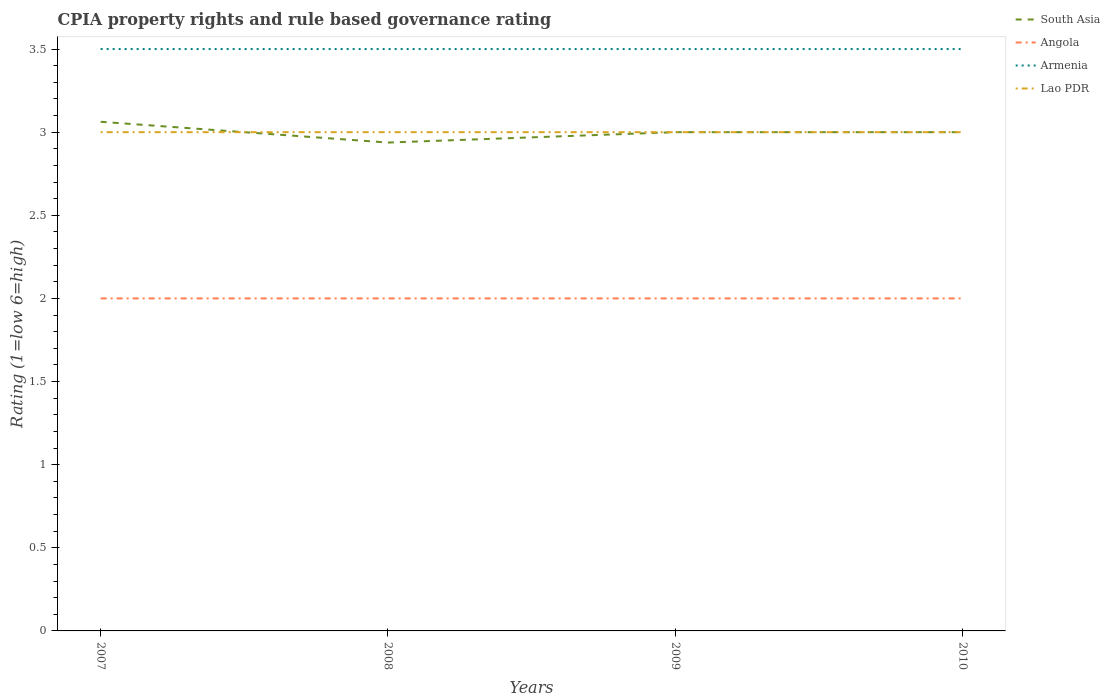How many different coloured lines are there?
Provide a short and direct response. 4. Does the line corresponding to Lao PDR intersect with the line corresponding to Angola?
Offer a very short reply. No. Is the number of lines equal to the number of legend labels?
Give a very brief answer. Yes. Across all years, what is the maximum CPIA rating in South Asia?
Keep it short and to the point. 2.94. In which year was the CPIA rating in Armenia maximum?
Give a very brief answer. 2007. What is the total CPIA rating in South Asia in the graph?
Keep it short and to the point. 0. What is the difference between the highest and the second highest CPIA rating in Lao PDR?
Make the answer very short. 0. What is the difference between the highest and the lowest CPIA rating in Angola?
Provide a succinct answer. 0. What is the difference between two consecutive major ticks on the Y-axis?
Offer a terse response. 0.5. Does the graph contain grids?
Your answer should be very brief. No. How many legend labels are there?
Make the answer very short. 4. How are the legend labels stacked?
Your answer should be very brief. Vertical. What is the title of the graph?
Your response must be concise. CPIA property rights and rule based governance rating. Does "United Kingdom" appear as one of the legend labels in the graph?
Give a very brief answer. No. What is the Rating (1=low 6=high) in South Asia in 2007?
Your response must be concise. 3.06. What is the Rating (1=low 6=high) in Angola in 2007?
Ensure brevity in your answer.  2. What is the Rating (1=low 6=high) in Lao PDR in 2007?
Your response must be concise. 3. What is the Rating (1=low 6=high) of South Asia in 2008?
Make the answer very short. 2.94. What is the Rating (1=low 6=high) of Angola in 2008?
Provide a short and direct response. 2. What is the Rating (1=low 6=high) in Armenia in 2008?
Your answer should be very brief. 3.5. What is the Rating (1=low 6=high) in South Asia in 2009?
Make the answer very short. 3. What is the Rating (1=low 6=high) in Angola in 2009?
Ensure brevity in your answer.  2. What is the Rating (1=low 6=high) in Armenia in 2009?
Your answer should be compact. 3.5. What is the Rating (1=low 6=high) in Armenia in 2010?
Keep it short and to the point. 3.5. What is the Rating (1=low 6=high) in Lao PDR in 2010?
Your answer should be compact. 3. Across all years, what is the maximum Rating (1=low 6=high) in South Asia?
Your answer should be very brief. 3.06. Across all years, what is the maximum Rating (1=low 6=high) in Angola?
Make the answer very short. 2. Across all years, what is the maximum Rating (1=low 6=high) of Armenia?
Give a very brief answer. 3.5. Across all years, what is the maximum Rating (1=low 6=high) in Lao PDR?
Your answer should be very brief. 3. Across all years, what is the minimum Rating (1=low 6=high) in South Asia?
Offer a terse response. 2.94. Across all years, what is the minimum Rating (1=low 6=high) in Angola?
Give a very brief answer. 2. Across all years, what is the minimum Rating (1=low 6=high) of Lao PDR?
Offer a terse response. 3. What is the total Rating (1=low 6=high) in Angola in the graph?
Your response must be concise. 8. What is the total Rating (1=low 6=high) of Lao PDR in the graph?
Provide a short and direct response. 12. What is the difference between the Rating (1=low 6=high) of Lao PDR in 2007 and that in 2008?
Offer a terse response. 0. What is the difference between the Rating (1=low 6=high) of South Asia in 2007 and that in 2009?
Your answer should be compact. 0.06. What is the difference between the Rating (1=low 6=high) of Armenia in 2007 and that in 2009?
Offer a terse response. 0. What is the difference between the Rating (1=low 6=high) of South Asia in 2007 and that in 2010?
Make the answer very short. 0.06. What is the difference between the Rating (1=low 6=high) of Angola in 2007 and that in 2010?
Keep it short and to the point. 0. What is the difference between the Rating (1=low 6=high) in South Asia in 2008 and that in 2009?
Provide a short and direct response. -0.06. What is the difference between the Rating (1=low 6=high) in South Asia in 2008 and that in 2010?
Provide a short and direct response. -0.06. What is the difference between the Rating (1=low 6=high) in Angola in 2008 and that in 2010?
Your answer should be compact. 0. What is the difference between the Rating (1=low 6=high) in Armenia in 2008 and that in 2010?
Ensure brevity in your answer.  0. What is the difference between the Rating (1=low 6=high) in Lao PDR in 2008 and that in 2010?
Offer a terse response. 0. What is the difference between the Rating (1=low 6=high) in South Asia in 2009 and that in 2010?
Your answer should be compact. 0. What is the difference between the Rating (1=low 6=high) in South Asia in 2007 and the Rating (1=low 6=high) in Armenia in 2008?
Offer a very short reply. -0.44. What is the difference between the Rating (1=low 6=high) of South Asia in 2007 and the Rating (1=low 6=high) of Lao PDR in 2008?
Your answer should be compact. 0.06. What is the difference between the Rating (1=low 6=high) of Angola in 2007 and the Rating (1=low 6=high) of Armenia in 2008?
Keep it short and to the point. -1.5. What is the difference between the Rating (1=low 6=high) in Armenia in 2007 and the Rating (1=low 6=high) in Lao PDR in 2008?
Offer a very short reply. 0.5. What is the difference between the Rating (1=low 6=high) in South Asia in 2007 and the Rating (1=low 6=high) in Angola in 2009?
Ensure brevity in your answer.  1.06. What is the difference between the Rating (1=low 6=high) of South Asia in 2007 and the Rating (1=low 6=high) of Armenia in 2009?
Ensure brevity in your answer.  -0.44. What is the difference between the Rating (1=low 6=high) in South Asia in 2007 and the Rating (1=low 6=high) in Lao PDR in 2009?
Your answer should be compact. 0.06. What is the difference between the Rating (1=low 6=high) in Angola in 2007 and the Rating (1=low 6=high) in Armenia in 2009?
Give a very brief answer. -1.5. What is the difference between the Rating (1=low 6=high) in Angola in 2007 and the Rating (1=low 6=high) in Lao PDR in 2009?
Your answer should be very brief. -1. What is the difference between the Rating (1=low 6=high) in South Asia in 2007 and the Rating (1=low 6=high) in Armenia in 2010?
Offer a very short reply. -0.44. What is the difference between the Rating (1=low 6=high) of South Asia in 2007 and the Rating (1=low 6=high) of Lao PDR in 2010?
Keep it short and to the point. 0.06. What is the difference between the Rating (1=low 6=high) in Armenia in 2007 and the Rating (1=low 6=high) in Lao PDR in 2010?
Offer a very short reply. 0.5. What is the difference between the Rating (1=low 6=high) in South Asia in 2008 and the Rating (1=low 6=high) in Armenia in 2009?
Keep it short and to the point. -0.56. What is the difference between the Rating (1=low 6=high) of South Asia in 2008 and the Rating (1=low 6=high) of Lao PDR in 2009?
Provide a short and direct response. -0.06. What is the difference between the Rating (1=low 6=high) of Angola in 2008 and the Rating (1=low 6=high) of Lao PDR in 2009?
Keep it short and to the point. -1. What is the difference between the Rating (1=low 6=high) of Armenia in 2008 and the Rating (1=low 6=high) of Lao PDR in 2009?
Your answer should be very brief. 0.5. What is the difference between the Rating (1=low 6=high) in South Asia in 2008 and the Rating (1=low 6=high) in Armenia in 2010?
Offer a very short reply. -0.56. What is the difference between the Rating (1=low 6=high) of South Asia in 2008 and the Rating (1=low 6=high) of Lao PDR in 2010?
Your response must be concise. -0.06. What is the difference between the Rating (1=low 6=high) of Angola in 2008 and the Rating (1=low 6=high) of Armenia in 2010?
Ensure brevity in your answer.  -1.5. What is the difference between the Rating (1=low 6=high) of Angola in 2008 and the Rating (1=low 6=high) of Lao PDR in 2010?
Your answer should be very brief. -1. What is the difference between the Rating (1=low 6=high) in Armenia in 2008 and the Rating (1=low 6=high) in Lao PDR in 2010?
Offer a very short reply. 0.5. What is the difference between the Rating (1=low 6=high) of South Asia in 2009 and the Rating (1=low 6=high) of Armenia in 2010?
Your response must be concise. -0.5. What is the difference between the Rating (1=low 6=high) in South Asia in 2009 and the Rating (1=low 6=high) in Lao PDR in 2010?
Offer a terse response. 0. What is the difference between the Rating (1=low 6=high) in Angola in 2009 and the Rating (1=low 6=high) in Lao PDR in 2010?
Offer a very short reply. -1. What is the difference between the Rating (1=low 6=high) of Armenia in 2009 and the Rating (1=low 6=high) of Lao PDR in 2010?
Offer a terse response. 0.5. What is the average Rating (1=low 6=high) in South Asia per year?
Keep it short and to the point. 3. In the year 2007, what is the difference between the Rating (1=low 6=high) of South Asia and Rating (1=low 6=high) of Armenia?
Make the answer very short. -0.44. In the year 2007, what is the difference between the Rating (1=low 6=high) of South Asia and Rating (1=low 6=high) of Lao PDR?
Your answer should be compact. 0.06. In the year 2007, what is the difference between the Rating (1=low 6=high) of Angola and Rating (1=low 6=high) of Lao PDR?
Your response must be concise. -1. In the year 2007, what is the difference between the Rating (1=low 6=high) of Armenia and Rating (1=low 6=high) of Lao PDR?
Provide a succinct answer. 0.5. In the year 2008, what is the difference between the Rating (1=low 6=high) in South Asia and Rating (1=low 6=high) in Angola?
Offer a terse response. 0.94. In the year 2008, what is the difference between the Rating (1=low 6=high) in South Asia and Rating (1=low 6=high) in Armenia?
Ensure brevity in your answer.  -0.56. In the year 2008, what is the difference between the Rating (1=low 6=high) of South Asia and Rating (1=low 6=high) of Lao PDR?
Your answer should be compact. -0.06. In the year 2008, what is the difference between the Rating (1=low 6=high) in Armenia and Rating (1=low 6=high) in Lao PDR?
Keep it short and to the point. 0.5. In the year 2009, what is the difference between the Rating (1=low 6=high) of South Asia and Rating (1=low 6=high) of Angola?
Make the answer very short. 1. In the year 2009, what is the difference between the Rating (1=low 6=high) of South Asia and Rating (1=low 6=high) of Armenia?
Ensure brevity in your answer.  -0.5. In the year 2009, what is the difference between the Rating (1=low 6=high) of South Asia and Rating (1=low 6=high) of Lao PDR?
Your answer should be compact. 0. In the year 2009, what is the difference between the Rating (1=low 6=high) in Angola and Rating (1=low 6=high) in Lao PDR?
Ensure brevity in your answer.  -1. In the year 2009, what is the difference between the Rating (1=low 6=high) of Armenia and Rating (1=low 6=high) of Lao PDR?
Your answer should be compact. 0.5. In the year 2010, what is the difference between the Rating (1=low 6=high) of South Asia and Rating (1=low 6=high) of Armenia?
Give a very brief answer. -0.5. In the year 2010, what is the difference between the Rating (1=low 6=high) in South Asia and Rating (1=low 6=high) in Lao PDR?
Your response must be concise. 0. In the year 2010, what is the difference between the Rating (1=low 6=high) of Angola and Rating (1=low 6=high) of Armenia?
Your answer should be very brief. -1.5. What is the ratio of the Rating (1=low 6=high) of South Asia in 2007 to that in 2008?
Give a very brief answer. 1.04. What is the ratio of the Rating (1=low 6=high) of Armenia in 2007 to that in 2008?
Your response must be concise. 1. What is the ratio of the Rating (1=low 6=high) in South Asia in 2007 to that in 2009?
Offer a terse response. 1.02. What is the ratio of the Rating (1=low 6=high) in Angola in 2007 to that in 2009?
Offer a very short reply. 1. What is the ratio of the Rating (1=low 6=high) in South Asia in 2007 to that in 2010?
Offer a very short reply. 1.02. What is the ratio of the Rating (1=low 6=high) in Angola in 2007 to that in 2010?
Your answer should be very brief. 1. What is the ratio of the Rating (1=low 6=high) in Armenia in 2007 to that in 2010?
Your answer should be compact. 1. What is the ratio of the Rating (1=low 6=high) in Lao PDR in 2007 to that in 2010?
Keep it short and to the point. 1. What is the ratio of the Rating (1=low 6=high) of South Asia in 2008 to that in 2009?
Make the answer very short. 0.98. What is the ratio of the Rating (1=low 6=high) in Angola in 2008 to that in 2009?
Your answer should be very brief. 1. What is the ratio of the Rating (1=low 6=high) of Armenia in 2008 to that in 2009?
Give a very brief answer. 1. What is the ratio of the Rating (1=low 6=high) of Lao PDR in 2008 to that in 2009?
Your response must be concise. 1. What is the ratio of the Rating (1=low 6=high) in South Asia in 2008 to that in 2010?
Your response must be concise. 0.98. What is the ratio of the Rating (1=low 6=high) of Angola in 2008 to that in 2010?
Offer a very short reply. 1. What is the difference between the highest and the second highest Rating (1=low 6=high) of South Asia?
Your answer should be very brief. 0.06. What is the difference between the highest and the second highest Rating (1=low 6=high) in Armenia?
Your response must be concise. 0. What is the difference between the highest and the second highest Rating (1=low 6=high) in Lao PDR?
Your answer should be compact. 0. What is the difference between the highest and the lowest Rating (1=low 6=high) of Angola?
Your response must be concise. 0. What is the difference between the highest and the lowest Rating (1=low 6=high) in Lao PDR?
Offer a very short reply. 0. 